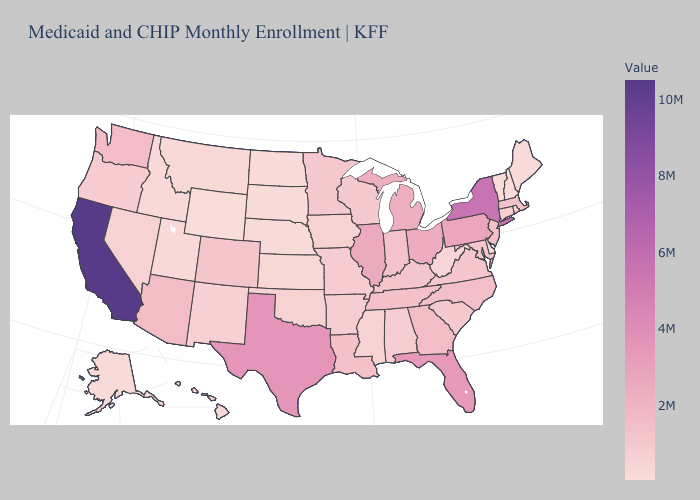Which states have the highest value in the USA?
Short answer required. California. Does Wyoming have the lowest value in the USA?
Concise answer only. Yes. Among the states that border Virginia , does North Carolina have the highest value?
Keep it brief. Yes. Is the legend a continuous bar?
Short answer required. Yes. Does the map have missing data?
Be succinct. No. 